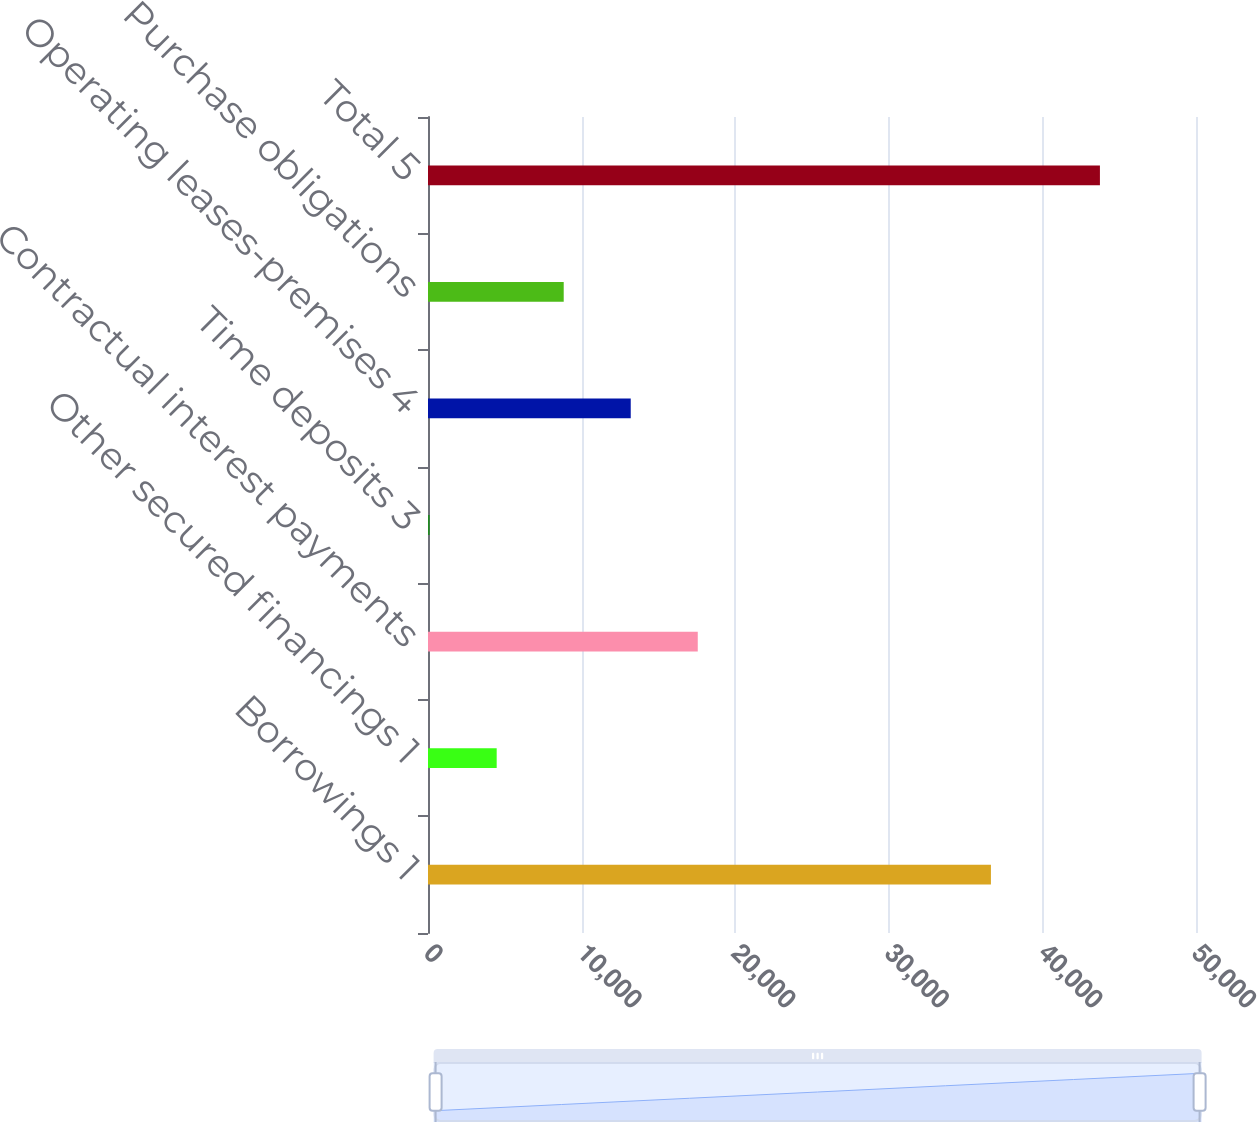<chart> <loc_0><loc_0><loc_500><loc_500><bar_chart><fcel>Borrowings 1<fcel>Other secured financings 1<fcel>Contractual interest payments<fcel>Time deposits 3<fcel>Operating leases-premises 4<fcel>Purchase obligations<fcel>Total 5<nl><fcel>36649<fcel>4471.7<fcel>17562.8<fcel>108<fcel>13199.1<fcel>8835.4<fcel>43745<nl></chart> 